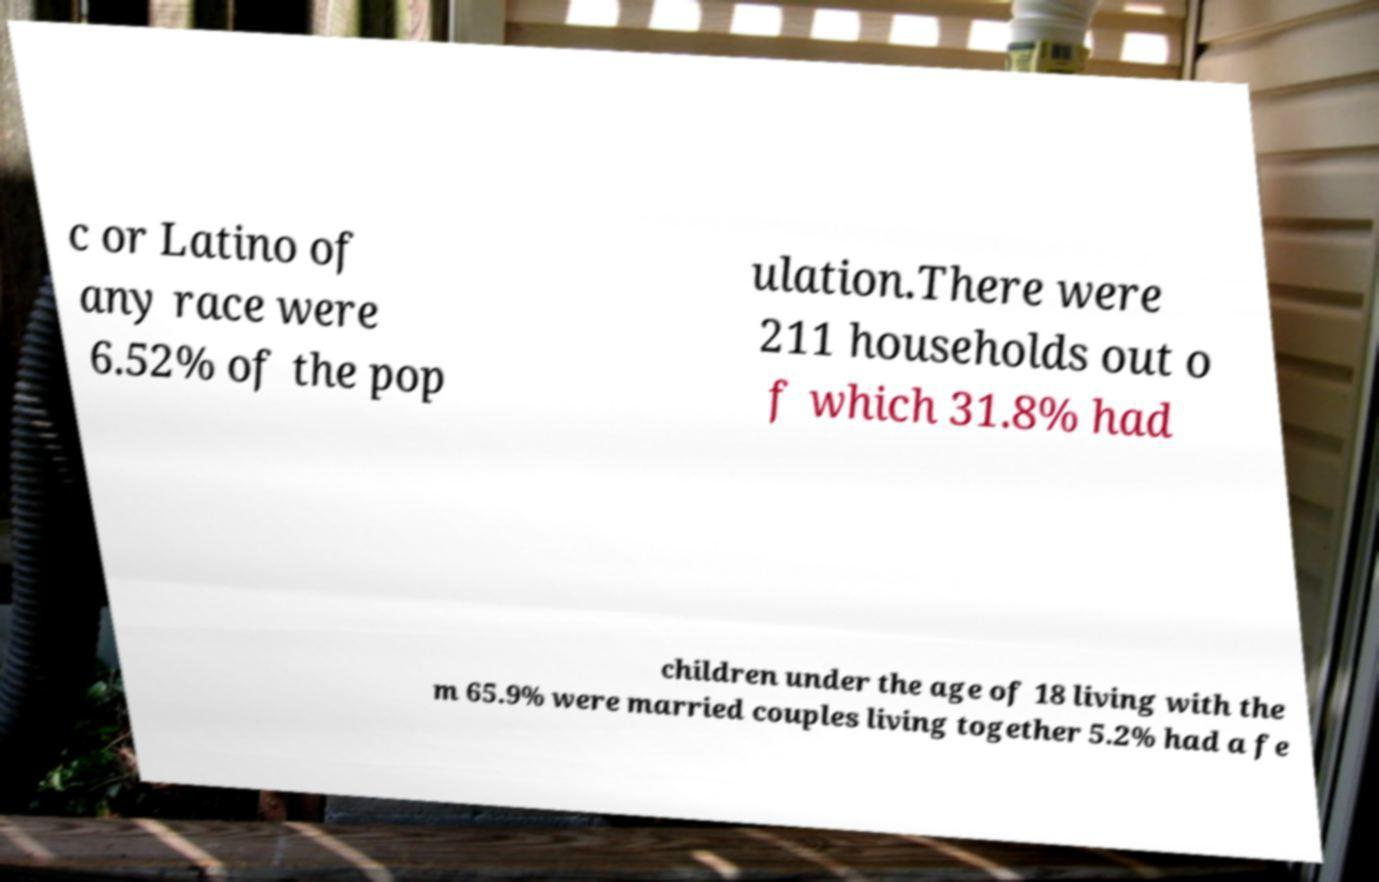Can you read and provide the text displayed in the image?This photo seems to have some interesting text. Can you extract and type it out for me? c or Latino of any race were 6.52% of the pop ulation.There were 211 households out o f which 31.8% had children under the age of 18 living with the m 65.9% were married couples living together 5.2% had a fe 